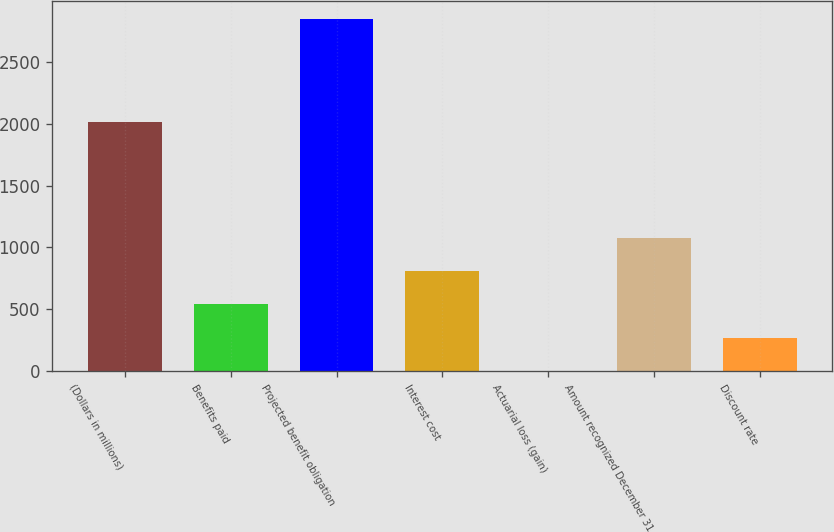Convert chart. <chart><loc_0><loc_0><loc_500><loc_500><bar_chart><fcel>(Dollars in millions)<fcel>Benefits paid<fcel>Projected benefit obligation<fcel>Interest cost<fcel>Actuarial loss (gain)<fcel>Amount recognized December 31<fcel>Discount rate<nl><fcel>2015<fcel>539.2<fcel>2848.6<fcel>807.8<fcel>2<fcel>1076.4<fcel>270.6<nl></chart> 